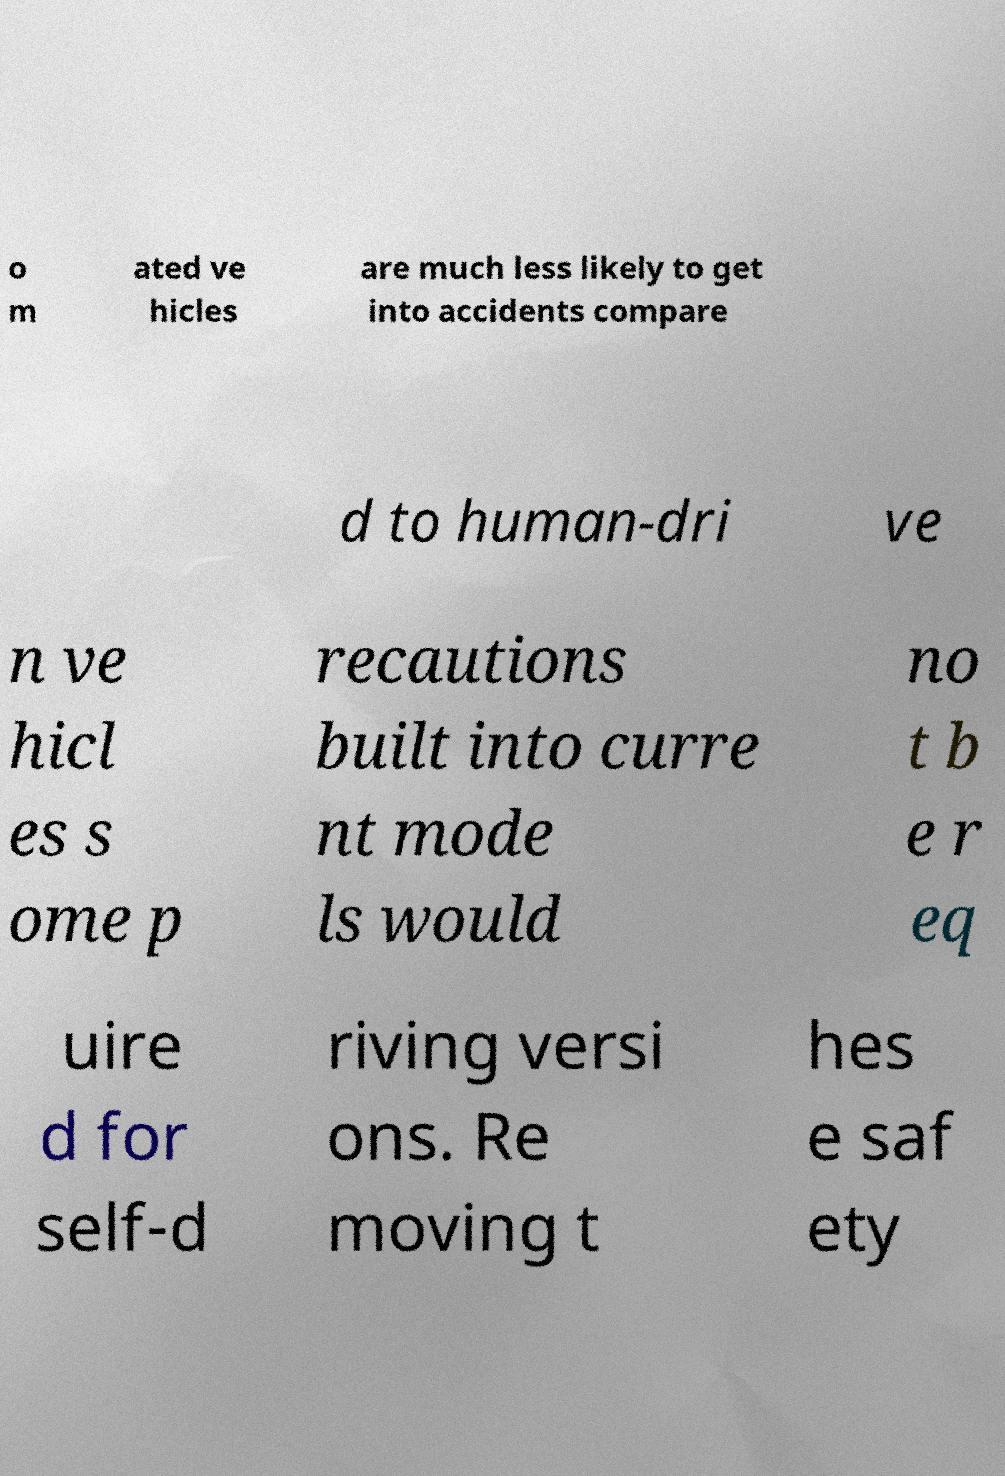Could you assist in decoding the text presented in this image and type it out clearly? o m ated ve hicles are much less likely to get into accidents compare d to human-dri ve n ve hicl es s ome p recautions built into curre nt mode ls would no t b e r eq uire d for self-d riving versi ons. Re moving t hes e saf ety 